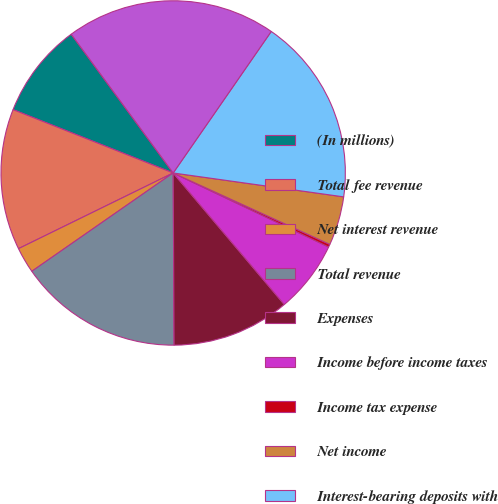Convert chart to OTSL. <chart><loc_0><loc_0><loc_500><loc_500><pie_chart><fcel>(In millions)<fcel>Total fee revenue<fcel>Net interest revenue<fcel>Total revenue<fcel>Expenses<fcel>Income before income taxes<fcel>Income tax expense<fcel>Net income<fcel>Interest-bearing deposits with<fcel>Other assets<nl><fcel>8.92%<fcel>13.24%<fcel>2.43%<fcel>15.41%<fcel>11.08%<fcel>6.76%<fcel>0.27%<fcel>4.59%<fcel>17.57%<fcel>19.73%<nl></chart> 